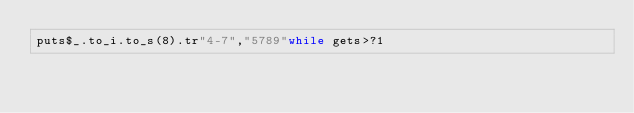<code> <loc_0><loc_0><loc_500><loc_500><_Ruby_>puts$_.to_i.to_s(8).tr"4-7","5789"while gets>?1</code> 